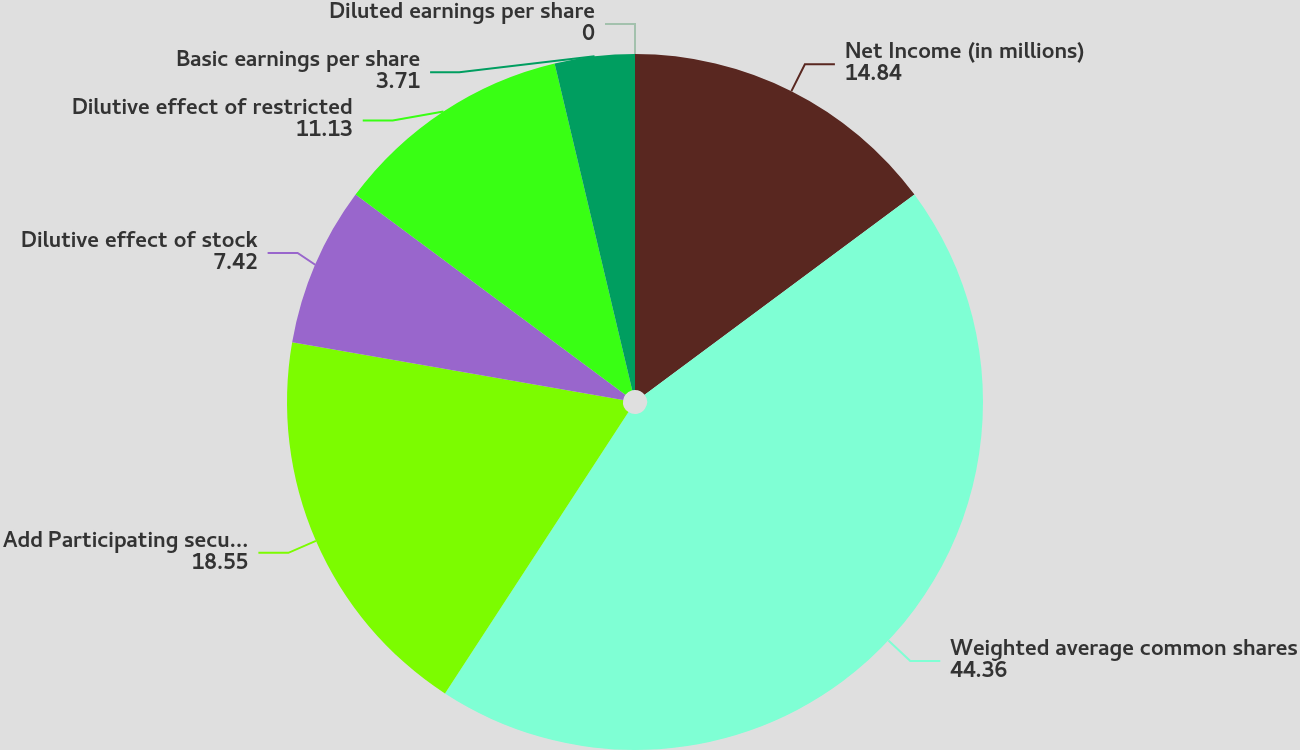Convert chart. <chart><loc_0><loc_0><loc_500><loc_500><pie_chart><fcel>Net Income (in millions)<fcel>Weighted average common shares<fcel>Add Participating securities<fcel>Dilutive effect of stock<fcel>Dilutive effect of restricted<fcel>Basic earnings per share<fcel>Diluted earnings per share<nl><fcel>14.84%<fcel>44.36%<fcel>18.55%<fcel>7.42%<fcel>11.13%<fcel>3.71%<fcel>0.0%<nl></chart> 